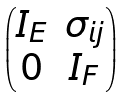Convert formula to latex. <formula><loc_0><loc_0><loc_500><loc_500>\begin{pmatrix} I _ { E } & \sigma _ { i j } \\ 0 & I _ { F } \end{pmatrix}</formula> 